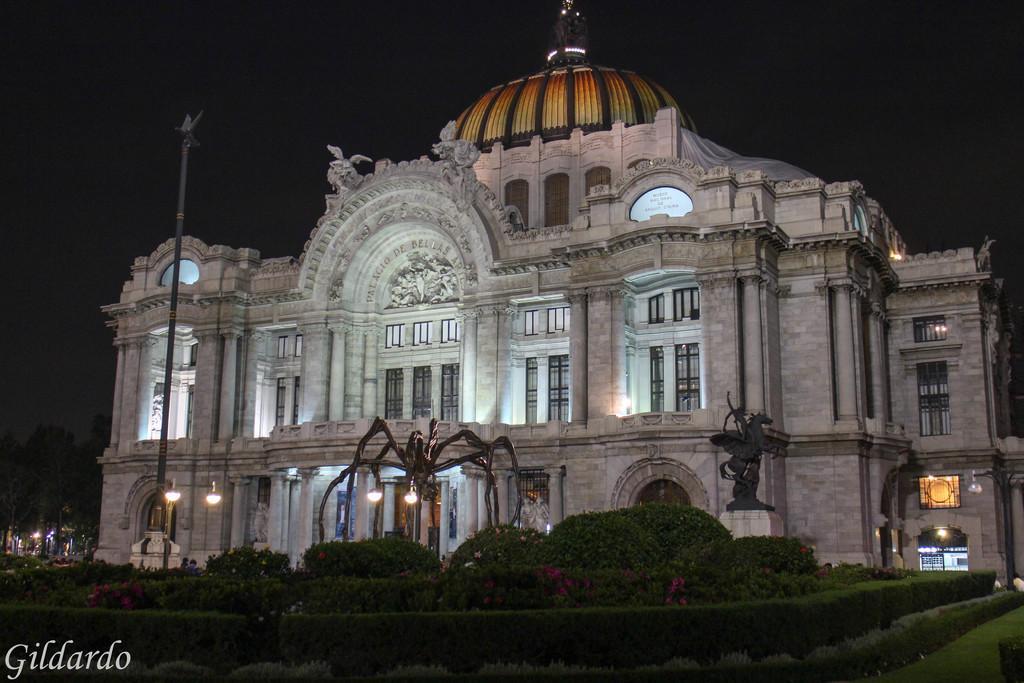How would you summarize this image in a sentence or two? In the left bottom corner, there is a watermark. In the background, there is a garden, near statues, there is a building, which is having glass windows, there are lights and the background is dark in color. 